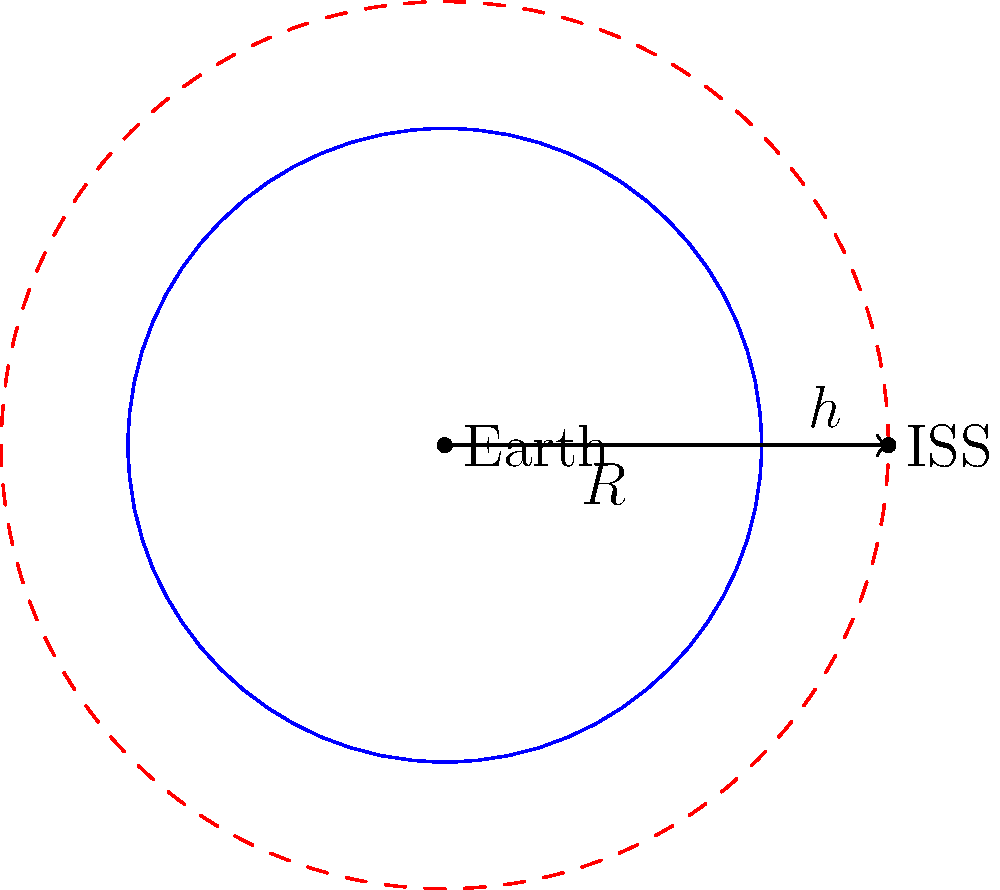As a supporter of Melania Trump's initiatives in STEM education, you're helping to promote space awareness. The International Space Station (ISS) orbits Earth at an altitude of approximately 400 km. If Earth's radius is about 6,371 km, what is the ISS's orbital radius in km? To find the orbital radius of the ISS, we need to follow these steps:

1. Understand that the orbital radius is the distance from the center of Earth to the ISS.
2. The orbital radius is the sum of Earth's radius and the ISS's altitude.
3. We're given:
   - Earth's radius (R) = 6,371 km
   - ISS altitude (h) = 400 km
4. Calculate the orbital radius using the formula:
   $$ \text{Orbital Radius} = R + h $$
5. Plug in the values:
   $$ \text{Orbital Radius} = 6,371 \text{ km} + 400 \text{ km} = 6,771 \text{ km} $$

Therefore, the ISS's orbital radius is 6,771 km.
Answer: 6,771 km 